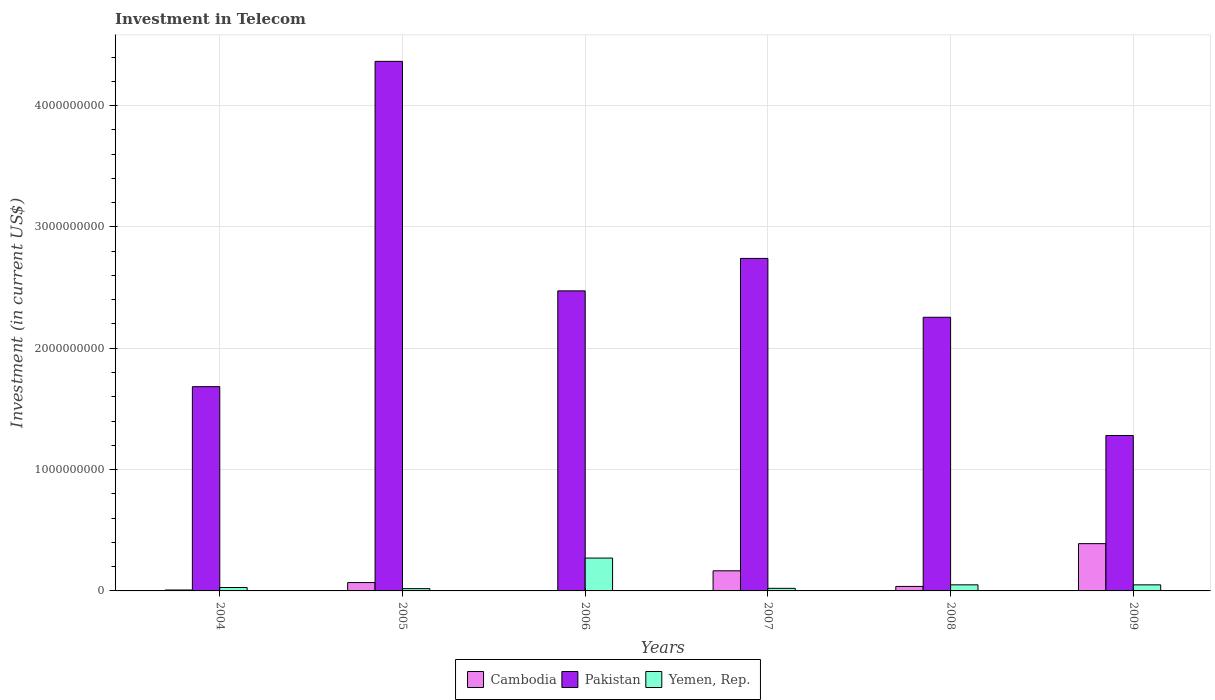How many different coloured bars are there?
Provide a succinct answer. 3. How many groups of bars are there?
Your response must be concise. 6. How many bars are there on the 2nd tick from the left?
Your response must be concise. 3. What is the amount invested in telecom in Cambodia in 2004?
Make the answer very short. 7.50e+06. Across all years, what is the maximum amount invested in telecom in Cambodia?
Your answer should be very brief. 3.90e+08. Across all years, what is the minimum amount invested in telecom in Yemen, Rep.?
Keep it short and to the point. 1.88e+07. In which year was the amount invested in telecom in Yemen, Rep. minimum?
Provide a succinct answer. 2005. What is the total amount invested in telecom in Cambodia in the graph?
Offer a terse response. 6.72e+08. What is the difference between the amount invested in telecom in Pakistan in 2007 and that in 2009?
Ensure brevity in your answer.  1.46e+09. What is the difference between the amount invested in telecom in Pakistan in 2007 and the amount invested in telecom in Yemen, Rep. in 2005?
Offer a very short reply. 2.72e+09. What is the average amount invested in telecom in Cambodia per year?
Provide a short and direct response. 1.12e+08. In the year 2004, what is the difference between the amount invested in telecom in Yemen, Rep. and amount invested in telecom in Pakistan?
Offer a very short reply. -1.66e+09. What is the ratio of the amount invested in telecom in Yemen, Rep. in 2006 to that in 2009?
Offer a terse response. 5.42. Is the amount invested in telecom in Yemen, Rep. in 2004 less than that in 2006?
Make the answer very short. Yes. Is the difference between the amount invested in telecom in Yemen, Rep. in 2007 and 2009 greater than the difference between the amount invested in telecom in Pakistan in 2007 and 2009?
Provide a short and direct response. No. What is the difference between the highest and the second highest amount invested in telecom in Yemen, Rep.?
Make the answer very short. 2.21e+08. What is the difference between the highest and the lowest amount invested in telecom in Pakistan?
Offer a very short reply. 3.08e+09. What does the 3rd bar from the left in 2008 represents?
Give a very brief answer. Yemen, Rep. What does the 1st bar from the right in 2007 represents?
Provide a short and direct response. Yemen, Rep. How many bars are there?
Provide a succinct answer. 18. Are all the bars in the graph horizontal?
Your answer should be very brief. No. How many years are there in the graph?
Your answer should be very brief. 6. Where does the legend appear in the graph?
Offer a terse response. Bottom center. What is the title of the graph?
Your answer should be compact. Investment in Telecom. What is the label or title of the X-axis?
Your response must be concise. Years. What is the label or title of the Y-axis?
Your answer should be compact. Investment (in current US$). What is the Investment (in current US$) of Cambodia in 2004?
Your response must be concise. 7.50e+06. What is the Investment (in current US$) of Pakistan in 2004?
Make the answer very short. 1.68e+09. What is the Investment (in current US$) in Yemen, Rep. in 2004?
Give a very brief answer. 2.80e+07. What is the Investment (in current US$) of Cambodia in 2005?
Offer a very short reply. 6.88e+07. What is the Investment (in current US$) in Pakistan in 2005?
Give a very brief answer. 4.36e+09. What is the Investment (in current US$) of Yemen, Rep. in 2005?
Keep it short and to the point. 1.88e+07. What is the Investment (in current US$) in Cambodia in 2006?
Offer a terse response. 3.10e+06. What is the Investment (in current US$) of Pakistan in 2006?
Provide a succinct answer. 2.47e+09. What is the Investment (in current US$) in Yemen, Rep. in 2006?
Offer a terse response. 2.71e+08. What is the Investment (in current US$) of Cambodia in 2007?
Your response must be concise. 1.66e+08. What is the Investment (in current US$) in Pakistan in 2007?
Make the answer very short. 2.74e+09. What is the Investment (in current US$) in Yemen, Rep. in 2007?
Ensure brevity in your answer.  2.13e+07. What is the Investment (in current US$) of Cambodia in 2008?
Keep it short and to the point. 3.70e+07. What is the Investment (in current US$) of Pakistan in 2008?
Provide a short and direct response. 2.26e+09. What is the Investment (in current US$) of Yemen, Rep. in 2008?
Provide a short and direct response. 5.01e+07. What is the Investment (in current US$) in Cambodia in 2009?
Make the answer very short. 3.90e+08. What is the Investment (in current US$) of Pakistan in 2009?
Keep it short and to the point. 1.28e+09. Across all years, what is the maximum Investment (in current US$) of Cambodia?
Make the answer very short. 3.90e+08. Across all years, what is the maximum Investment (in current US$) of Pakistan?
Keep it short and to the point. 4.36e+09. Across all years, what is the maximum Investment (in current US$) in Yemen, Rep.?
Keep it short and to the point. 2.71e+08. Across all years, what is the minimum Investment (in current US$) of Cambodia?
Your answer should be compact. 3.10e+06. Across all years, what is the minimum Investment (in current US$) in Pakistan?
Your response must be concise. 1.28e+09. Across all years, what is the minimum Investment (in current US$) in Yemen, Rep.?
Keep it short and to the point. 1.88e+07. What is the total Investment (in current US$) in Cambodia in the graph?
Offer a very short reply. 6.72e+08. What is the total Investment (in current US$) in Pakistan in the graph?
Your response must be concise. 1.48e+1. What is the total Investment (in current US$) of Yemen, Rep. in the graph?
Make the answer very short. 4.39e+08. What is the difference between the Investment (in current US$) of Cambodia in 2004 and that in 2005?
Provide a short and direct response. -6.13e+07. What is the difference between the Investment (in current US$) of Pakistan in 2004 and that in 2005?
Your answer should be compact. -2.68e+09. What is the difference between the Investment (in current US$) of Yemen, Rep. in 2004 and that in 2005?
Provide a succinct answer. 9.20e+06. What is the difference between the Investment (in current US$) of Cambodia in 2004 and that in 2006?
Provide a succinct answer. 4.40e+06. What is the difference between the Investment (in current US$) in Pakistan in 2004 and that in 2006?
Your answer should be compact. -7.90e+08. What is the difference between the Investment (in current US$) in Yemen, Rep. in 2004 and that in 2006?
Make the answer very short. -2.43e+08. What is the difference between the Investment (in current US$) in Cambodia in 2004 and that in 2007?
Offer a very short reply. -1.58e+08. What is the difference between the Investment (in current US$) in Pakistan in 2004 and that in 2007?
Your answer should be compact. -1.06e+09. What is the difference between the Investment (in current US$) in Yemen, Rep. in 2004 and that in 2007?
Ensure brevity in your answer.  6.70e+06. What is the difference between the Investment (in current US$) in Cambodia in 2004 and that in 2008?
Your answer should be very brief. -2.95e+07. What is the difference between the Investment (in current US$) of Pakistan in 2004 and that in 2008?
Offer a very short reply. -5.72e+08. What is the difference between the Investment (in current US$) of Yemen, Rep. in 2004 and that in 2008?
Your answer should be very brief. -2.21e+07. What is the difference between the Investment (in current US$) of Cambodia in 2004 and that in 2009?
Give a very brief answer. -3.82e+08. What is the difference between the Investment (in current US$) of Pakistan in 2004 and that in 2009?
Offer a very short reply. 4.02e+08. What is the difference between the Investment (in current US$) of Yemen, Rep. in 2004 and that in 2009?
Provide a succinct answer. -2.20e+07. What is the difference between the Investment (in current US$) of Cambodia in 2005 and that in 2006?
Keep it short and to the point. 6.57e+07. What is the difference between the Investment (in current US$) of Pakistan in 2005 and that in 2006?
Make the answer very short. 1.89e+09. What is the difference between the Investment (in current US$) of Yemen, Rep. in 2005 and that in 2006?
Give a very brief answer. -2.52e+08. What is the difference between the Investment (in current US$) in Cambodia in 2005 and that in 2007?
Offer a very short reply. -9.70e+07. What is the difference between the Investment (in current US$) in Pakistan in 2005 and that in 2007?
Make the answer very short. 1.62e+09. What is the difference between the Investment (in current US$) of Yemen, Rep. in 2005 and that in 2007?
Make the answer very short. -2.50e+06. What is the difference between the Investment (in current US$) of Cambodia in 2005 and that in 2008?
Your response must be concise. 3.18e+07. What is the difference between the Investment (in current US$) in Pakistan in 2005 and that in 2008?
Your answer should be compact. 2.11e+09. What is the difference between the Investment (in current US$) of Yemen, Rep. in 2005 and that in 2008?
Provide a short and direct response. -3.13e+07. What is the difference between the Investment (in current US$) in Cambodia in 2005 and that in 2009?
Provide a succinct answer. -3.21e+08. What is the difference between the Investment (in current US$) of Pakistan in 2005 and that in 2009?
Offer a terse response. 3.08e+09. What is the difference between the Investment (in current US$) in Yemen, Rep. in 2005 and that in 2009?
Your response must be concise. -3.12e+07. What is the difference between the Investment (in current US$) of Cambodia in 2006 and that in 2007?
Your answer should be very brief. -1.63e+08. What is the difference between the Investment (in current US$) in Pakistan in 2006 and that in 2007?
Keep it short and to the point. -2.68e+08. What is the difference between the Investment (in current US$) of Yemen, Rep. in 2006 and that in 2007?
Provide a succinct answer. 2.50e+08. What is the difference between the Investment (in current US$) of Cambodia in 2006 and that in 2008?
Your response must be concise. -3.39e+07. What is the difference between the Investment (in current US$) of Pakistan in 2006 and that in 2008?
Provide a succinct answer. 2.18e+08. What is the difference between the Investment (in current US$) in Yemen, Rep. in 2006 and that in 2008?
Your answer should be very brief. 2.21e+08. What is the difference between the Investment (in current US$) in Cambodia in 2006 and that in 2009?
Your answer should be compact. -3.86e+08. What is the difference between the Investment (in current US$) of Pakistan in 2006 and that in 2009?
Make the answer very short. 1.19e+09. What is the difference between the Investment (in current US$) in Yemen, Rep. in 2006 and that in 2009?
Your answer should be very brief. 2.21e+08. What is the difference between the Investment (in current US$) in Cambodia in 2007 and that in 2008?
Offer a very short reply. 1.29e+08. What is the difference between the Investment (in current US$) of Pakistan in 2007 and that in 2008?
Provide a short and direct response. 4.85e+08. What is the difference between the Investment (in current US$) of Yemen, Rep. in 2007 and that in 2008?
Offer a terse response. -2.88e+07. What is the difference between the Investment (in current US$) of Cambodia in 2007 and that in 2009?
Your response must be concise. -2.24e+08. What is the difference between the Investment (in current US$) of Pakistan in 2007 and that in 2009?
Offer a terse response. 1.46e+09. What is the difference between the Investment (in current US$) of Yemen, Rep. in 2007 and that in 2009?
Provide a succinct answer. -2.87e+07. What is the difference between the Investment (in current US$) of Cambodia in 2008 and that in 2009?
Your answer should be compact. -3.53e+08. What is the difference between the Investment (in current US$) in Pakistan in 2008 and that in 2009?
Provide a short and direct response. 9.74e+08. What is the difference between the Investment (in current US$) in Cambodia in 2004 and the Investment (in current US$) in Pakistan in 2005?
Provide a short and direct response. -4.36e+09. What is the difference between the Investment (in current US$) in Cambodia in 2004 and the Investment (in current US$) in Yemen, Rep. in 2005?
Offer a very short reply. -1.13e+07. What is the difference between the Investment (in current US$) in Pakistan in 2004 and the Investment (in current US$) in Yemen, Rep. in 2005?
Your answer should be compact. 1.66e+09. What is the difference between the Investment (in current US$) in Cambodia in 2004 and the Investment (in current US$) in Pakistan in 2006?
Your answer should be very brief. -2.47e+09. What is the difference between the Investment (in current US$) in Cambodia in 2004 and the Investment (in current US$) in Yemen, Rep. in 2006?
Provide a short and direct response. -2.63e+08. What is the difference between the Investment (in current US$) in Pakistan in 2004 and the Investment (in current US$) in Yemen, Rep. in 2006?
Provide a short and direct response. 1.41e+09. What is the difference between the Investment (in current US$) in Cambodia in 2004 and the Investment (in current US$) in Pakistan in 2007?
Ensure brevity in your answer.  -2.73e+09. What is the difference between the Investment (in current US$) of Cambodia in 2004 and the Investment (in current US$) of Yemen, Rep. in 2007?
Offer a terse response. -1.38e+07. What is the difference between the Investment (in current US$) in Pakistan in 2004 and the Investment (in current US$) in Yemen, Rep. in 2007?
Offer a very short reply. 1.66e+09. What is the difference between the Investment (in current US$) in Cambodia in 2004 and the Investment (in current US$) in Pakistan in 2008?
Provide a succinct answer. -2.25e+09. What is the difference between the Investment (in current US$) in Cambodia in 2004 and the Investment (in current US$) in Yemen, Rep. in 2008?
Ensure brevity in your answer.  -4.26e+07. What is the difference between the Investment (in current US$) in Pakistan in 2004 and the Investment (in current US$) in Yemen, Rep. in 2008?
Your answer should be compact. 1.63e+09. What is the difference between the Investment (in current US$) in Cambodia in 2004 and the Investment (in current US$) in Pakistan in 2009?
Your answer should be compact. -1.27e+09. What is the difference between the Investment (in current US$) in Cambodia in 2004 and the Investment (in current US$) in Yemen, Rep. in 2009?
Provide a short and direct response. -4.25e+07. What is the difference between the Investment (in current US$) of Pakistan in 2004 and the Investment (in current US$) of Yemen, Rep. in 2009?
Keep it short and to the point. 1.63e+09. What is the difference between the Investment (in current US$) in Cambodia in 2005 and the Investment (in current US$) in Pakistan in 2006?
Your answer should be very brief. -2.40e+09. What is the difference between the Investment (in current US$) of Cambodia in 2005 and the Investment (in current US$) of Yemen, Rep. in 2006?
Offer a terse response. -2.02e+08. What is the difference between the Investment (in current US$) in Pakistan in 2005 and the Investment (in current US$) in Yemen, Rep. in 2006?
Offer a very short reply. 4.09e+09. What is the difference between the Investment (in current US$) of Cambodia in 2005 and the Investment (in current US$) of Pakistan in 2007?
Offer a very short reply. -2.67e+09. What is the difference between the Investment (in current US$) of Cambodia in 2005 and the Investment (in current US$) of Yemen, Rep. in 2007?
Provide a succinct answer. 4.75e+07. What is the difference between the Investment (in current US$) of Pakistan in 2005 and the Investment (in current US$) of Yemen, Rep. in 2007?
Provide a succinct answer. 4.34e+09. What is the difference between the Investment (in current US$) of Cambodia in 2005 and the Investment (in current US$) of Pakistan in 2008?
Give a very brief answer. -2.19e+09. What is the difference between the Investment (in current US$) in Cambodia in 2005 and the Investment (in current US$) in Yemen, Rep. in 2008?
Provide a succinct answer. 1.87e+07. What is the difference between the Investment (in current US$) of Pakistan in 2005 and the Investment (in current US$) of Yemen, Rep. in 2008?
Provide a short and direct response. 4.31e+09. What is the difference between the Investment (in current US$) in Cambodia in 2005 and the Investment (in current US$) in Pakistan in 2009?
Provide a short and direct response. -1.21e+09. What is the difference between the Investment (in current US$) of Cambodia in 2005 and the Investment (in current US$) of Yemen, Rep. in 2009?
Your answer should be very brief. 1.88e+07. What is the difference between the Investment (in current US$) of Pakistan in 2005 and the Investment (in current US$) of Yemen, Rep. in 2009?
Offer a terse response. 4.31e+09. What is the difference between the Investment (in current US$) in Cambodia in 2006 and the Investment (in current US$) in Pakistan in 2007?
Provide a short and direct response. -2.74e+09. What is the difference between the Investment (in current US$) of Cambodia in 2006 and the Investment (in current US$) of Yemen, Rep. in 2007?
Your answer should be very brief. -1.82e+07. What is the difference between the Investment (in current US$) of Pakistan in 2006 and the Investment (in current US$) of Yemen, Rep. in 2007?
Ensure brevity in your answer.  2.45e+09. What is the difference between the Investment (in current US$) of Cambodia in 2006 and the Investment (in current US$) of Pakistan in 2008?
Your response must be concise. -2.25e+09. What is the difference between the Investment (in current US$) of Cambodia in 2006 and the Investment (in current US$) of Yemen, Rep. in 2008?
Offer a terse response. -4.70e+07. What is the difference between the Investment (in current US$) of Pakistan in 2006 and the Investment (in current US$) of Yemen, Rep. in 2008?
Your answer should be compact. 2.42e+09. What is the difference between the Investment (in current US$) of Cambodia in 2006 and the Investment (in current US$) of Pakistan in 2009?
Provide a short and direct response. -1.28e+09. What is the difference between the Investment (in current US$) in Cambodia in 2006 and the Investment (in current US$) in Yemen, Rep. in 2009?
Make the answer very short. -4.69e+07. What is the difference between the Investment (in current US$) of Pakistan in 2006 and the Investment (in current US$) of Yemen, Rep. in 2009?
Provide a short and direct response. 2.42e+09. What is the difference between the Investment (in current US$) in Cambodia in 2007 and the Investment (in current US$) in Pakistan in 2008?
Offer a very short reply. -2.09e+09. What is the difference between the Investment (in current US$) in Cambodia in 2007 and the Investment (in current US$) in Yemen, Rep. in 2008?
Keep it short and to the point. 1.16e+08. What is the difference between the Investment (in current US$) of Pakistan in 2007 and the Investment (in current US$) of Yemen, Rep. in 2008?
Your answer should be compact. 2.69e+09. What is the difference between the Investment (in current US$) in Cambodia in 2007 and the Investment (in current US$) in Pakistan in 2009?
Provide a succinct answer. -1.12e+09. What is the difference between the Investment (in current US$) of Cambodia in 2007 and the Investment (in current US$) of Yemen, Rep. in 2009?
Ensure brevity in your answer.  1.16e+08. What is the difference between the Investment (in current US$) of Pakistan in 2007 and the Investment (in current US$) of Yemen, Rep. in 2009?
Your answer should be very brief. 2.69e+09. What is the difference between the Investment (in current US$) of Cambodia in 2008 and the Investment (in current US$) of Pakistan in 2009?
Offer a very short reply. -1.24e+09. What is the difference between the Investment (in current US$) of Cambodia in 2008 and the Investment (in current US$) of Yemen, Rep. in 2009?
Provide a succinct answer. -1.30e+07. What is the difference between the Investment (in current US$) of Pakistan in 2008 and the Investment (in current US$) of Yemen, Rep. in 2009?
Your answer should be very brief. 2.21e+09. What is the average Investment (in current US$) in Cambodia per year?
Offer a terse response. 1.12e+08. What is the average Investment (in current US$) in Pakistan per year?
Provide a succinct answer. 2.47e+09. What is the average Investment (in current US$) of Yemen, Rep. per year?
Your answer should be compact. 7.32e+07. In the year 2004, what is the difference between the Investment (in current US$) of Cambodia and Investment (in current US$) of Pakistan?
Offer a very short reply. -1.68e+09. In the year 2004, what is the difference between the Investment (in current US$) in Cambodia and Investment (in current US$) in Yemen, Rep.?
Ensure brevity in your answer.  -2.05e+07. In the year 2004, what is the difference between the Investment (in current US$) in Pakistan and Investment (in current US$) in Yemen, Rep.?
Offer a terse response. 1.66e+09. In the year 2005, what is the difference between the Investment (in current US$) in Cambodia and Investment (in current US$) in Pakistan?
Offer a very short reply. -4.30e+09. In the year 2005, what is the difference between the Investment (in current US$) in Cambodia and Investment (in current US$) in Yemen, Rep.?
Provide a short and direct response. 5.00e+07. In the year 2005, what is the difference between the Investment (in current US$) of Pakistan and Investment (in current US$) of Yemen, Rep.?
Ensure brevity in your answer.  4.35e+09. In the year 2006, what is the difference between the Investment (in current US$) of Cambodia and Investment (in current US$) of Pakistan?
Your answer should be compact. -2.47e+09. In the year 2006, what is the difference between the Investment (in current US$) in Cambodia and Investment (in current US$) in Yemen, Rep.?
Keep it short and to the point. -2.68e+08. In the year 2006, what is the difference between the Investment (in current US$) in Pakistan and Investment (in current US$) in Yemen, Rep.?
Give a very brief answer. 2.20e+09. In the year 2007, what is the difference between the Investment (in current US$) in Cambodia and Investment (in current US$) in Pakistan?
Offer a very short reply. -2.57e+09. In the year 2007, what is the difference between the Investment (in current US$) in Cambodia and Investment (in current US$) in Yemen, Rep.?
Make the answer very short. 1.44e+08. In the year 2007, what is the difference between the Investment (in current US$) in Pakistan and Investment (in current US$) in Yemen, Rep.?
Your answer should be very brief. 2.72e+09. In the year 2008, what is the difference between the Investment (in current US$) of Cambodia and Investment (in current US$) of Pakistan?
Keep it short and to the point. -2.22e+09. In the year 2008, what is the difference between the Investment (in current US$) in Cambodia and Investment (in current US$) in Yemen, Rep.?
Your response must be concise. -1.31e+07. In the year 2008, what is the difference between the Investment (in current US$) in Pakistan and Investment (in current US$) in Yemen, Rep.?
Provide a succinct answer. 2.21e+09. In the year 2009, what is the difference between the Investment (in current US$) in Cambodia and Investment (in current US$) in Pakistan?
Provide a succinct answer. -8.91e+08. In the year 2009, what is the difference between the Investment (in current US$) in Cambodia and Investment (in current US$) in Yemen, Rep.?
Make the answer very short. 3.40e+08. In the year 2009, what is the difference between the Investment (in current US$) in Pakistan and Investment (in current US$) in Yemen, Rep.?
Your answer should be very brief. 1.23e+09. What is the ratio of the Investment (in current US$) of Cambodia in 2004 to that in 2005?
Your response must be concise. 0.11. What is the ratio of the Investment (in current US$) of Pakistan in 2004 to that in 2005?
Your answer should be very brief. 0.39. What is the ratio of the Investment (in current US$) of Yemen, Rep. in 2004 to that in 2005?
Ensure brevity in your answer.  1.49. What is the ratio of the Investment (in current US$) in Cambodia in 2004 to that in 2006?
Ensure brevity in your answer.  2.42. What is the ratio of the Investment (in current US$) in Pakistan in 2004 to that in 2006?
Your answer should be compact. 0.68. What is the ratio of the Investment (in current US$) in Yemen, Rep. in 2004 to that in 2006?
Provide a short and direct response. 0.1. What is the ratio of the Investment (in current US$) in Cambodia in 2004 to that in 2007?
Offer a terse response. 0.05. What is the ratio of the Investment (in current US$) in Pakistan in 2004 to that in 2007?
Give a very brief answer. 0.61. What is the ratio of the Investment (in current US$) in Yemen, Rep. in 2004 to that in 2007?
Keep it short and to the point. 1.31. What is the ratio of the Investment (in current US$) of Cambodia in 2004 to that in 2008?
Keep it short and to the point. 0.2. What is the ratio of the Investment (in current US$) in Pakistan in 2004 to that in 2008?
Offer a terse response. 0.75. What is the ratio of the Investment (in current US$) in Yemen, Rep. in 2004 to that in 2008?
Provide a short and direct response. 0.56. What is the ratio of the Investment (in current US$) of Cambodia in 2004 to that in 2009?
Keep it short and to the point. 0.02. What is the ratio of the Investment (in current US$) of Pakistan in 2004 to that in 2009?
Provide a short and direct response. 1.31. What is the ratio of the Investment (in current US$) in Yemen, Rep. in 2004 to that in 2009?
Your answer should be compact. 0.56. What is the ratio of the Investment (in current US$) in Cambodia in 2005 to that in 2006?
Give a very brief answer. 22.19. What is the ratio of the Investment (in current US$) of Pakistan in 2005 to that in 2006?
Keep it short and to the point. 1.76. What is the ratio of the Investment (in current US$) in Yemen, Rep. in 2005 to that in 2006?
Provide a short and direct response. 0.07. What is the ratio of the Investment (in current US$) of Cambodia in 2005 to that in 2007?
Your response must be concise. 0.41. What is the ratio of the Investment (in current US$) of Pakistan in 2005 to that in 2007?
Offer a terse response. 1.59. What is the ratio of the Investment (in current US$) in Yemen, Rep. in 2005 to that in 2007?
Your answer should be compact. 0.88. What is the ratio of the Investment (in current US$) in Cambodia in 2005 to that in 2008?
Make the answer very short. 1.86. What is the ratio of the Investment (in current US$) of Pakistan in 2005 to that in 2008?
Your response must be concise. 1.94. What is the ratio of the Investment (in current US$) in Yemen, Rep. in 2005 to that in 2008?
Give a very brief answer. 0.38. What is the ratio of the Investment (in current US$) in Cambodia in 2005 to that in 2009?
Ensure brevity in your answer.  0.18. What is the ratio of the Investment (in current US$) of Pakistan in 2005 to that in 2009?
Provide a short and direct response. 3.41. What is the ratio of the Investment (in current US$) of Yemen, Rep. in 2005 to that in 2009?
Your answer should be compact. 0.38. What is the ratio of the Investment (in current US$) of Cambodia in 2006 to that in 2007?
Ensure brevity in your answer.  0.02. What is the ratio of the Investment (in current US$) of Pakistan in 2006 to that in 2007?
Offer a terse response. 0.9. What is the ratio of the Investment (in current US$) in Yemen, Rep. in 2006 to that in 2007?
Ensure brevity in your answer.  12.71. What is the ratio of the Investment (in current US$) of Cambodia in 2006 to that in 2008?
Your answer should be very brief. 0.08. What is the ratio of the Investment (in current US$) in Pakistan in 2006 to that in 2008?
Your response must be concise. 1.1. What is the ratio of the Investment (in current US$) of Yemen, Rep. in 2006 to that in 2008?
Provide a succinct answer. 5.41. What is the ratio of the Investment (in current US$) of Cambodia in 2006 to that in 2009?
Your answer should be very brief. 0.01. What is the ratio of the Investment (in current US$) of Pakistan in 2006 to that in 2009?
Offer a terse response. 1.93. What is the ratio of the Investment (in current US$) in Yemen, Rep. in 2006 to that in 2009?
Make the answer very short. 5.42. What is the ratio of the Investment (in current US$) of Cambodia in 2007 to that in 2008?
Offer a very short reply. 4.48. What is the ratio of the Investment (in current US$) in Pakistan in 2007 to that in 2008?
Your answer should be very brief. 1.22. What is the ratio of the Investment (in current US$) of Yemen, Rep. in 2007 to that in 2008?
Your answer should be very brief. 0.43. What is the ratio of the Investment (in current US$) of Cambodia in 2007 to that in 2009?
Your answer should be very brief. 0.43. What is the ratio of the Investment (in current US$) in Pakistan in 2007 to that in 2009?
Your answer should be very brief. 2.14. What is the ratio of the Investment (in current US$) of Yemen, Rep. in 2007 to that in 2009?
Offer a very short reply. 0.43. What is the ratio of the Investment (in current US$) of Cambodia in 2008 to that in 2009?
Your answer should be very brief. 0.1. What is the ratio of the Investment (in current US$) of Pakistan in 2008 to that in 2009?
Keep it short and to the point. 1.76. What is the difference between the highest and the second highest Investment (in current US$) of Cambodia?
Your response must be concise. 2.24e+08. What is the difference between the highest and the second highest Investment (in current US$) in Pakistan?
Offer a terse response. 1.62e+09. What is the difference between the highest and the second highest Investment (in current US$) in Yemen, Rep.?
Ensure brevity in your answer.  2.21e+08. What is the difference between the highest and the lowest Investment (in current US$) in Cambodia?
Your answer should be compact. 3.86e+08. What is the difference between the highest and the lowest Investment (in current US$) in Pakistan?
Offer a terse response. 3.08e+09. What is the difference between the highest and the lowest Investment (in current US$) of Yemen, Rep.?
Offer a terse response. 2.52e+08. 